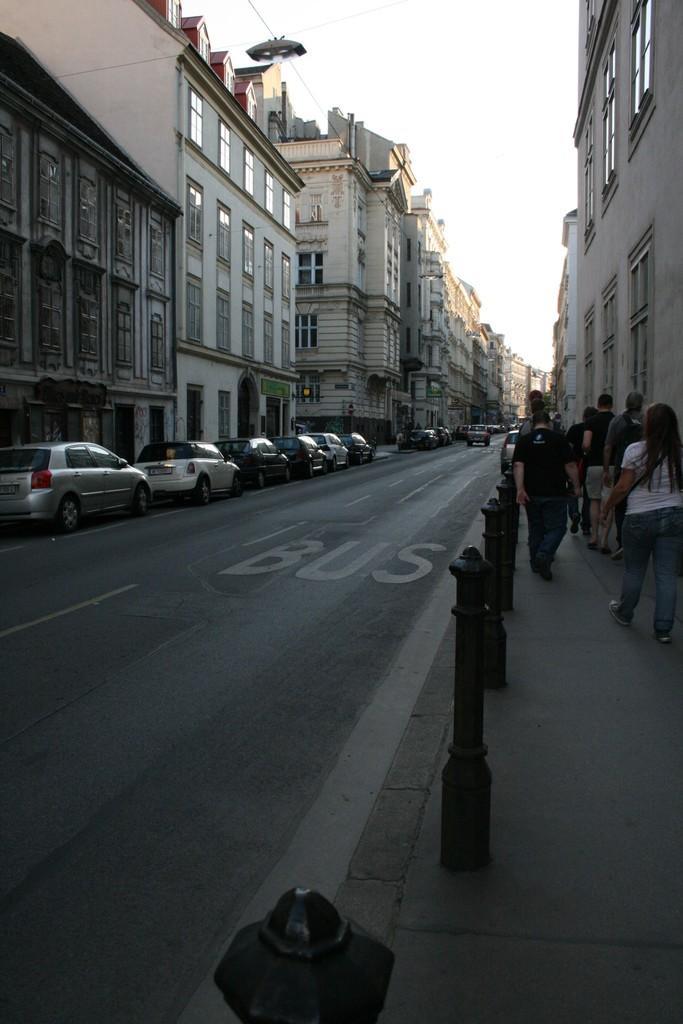Can you describe this image briefly? In this image there is a road, on the road there are few poles, vehicles visible, at the top there is the sky, beside the road there are few persons walking in front of building on the right side. 